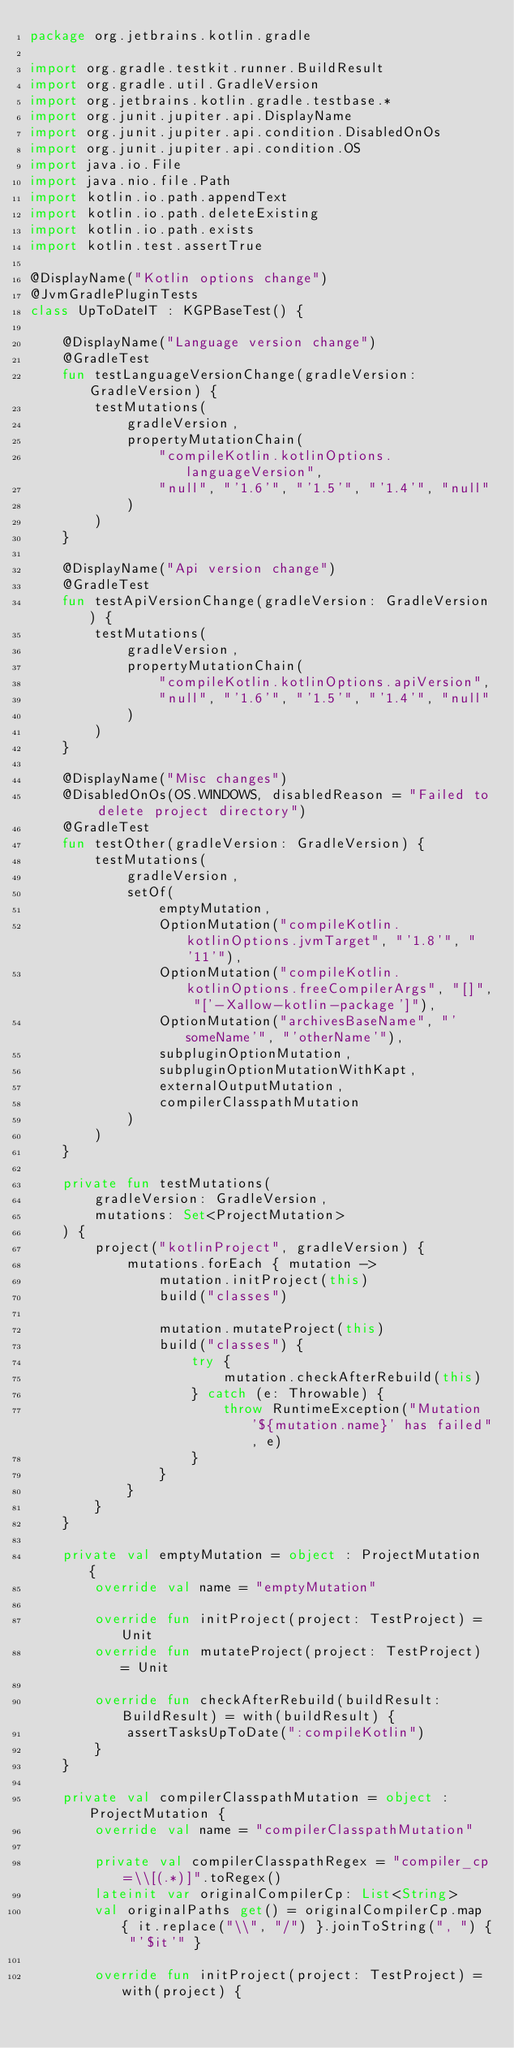<code> <loc_0><loc_0><loc_500><loc_500><_Kotlin_>package org.jetbrains.kotlin.gradle

import org.gradle.testkit.runner.BuildResult
import org.gradle.util.GradleVersion
import org.jetbrains.kotlin.gradle.testbase.*
import org.junit.jupiter.api.DisplayName
import org.junit.jupiter.api.condition.DisabledOnOs
import org.junit.jupiter.api.condition.OS
import java.io.File
import java.nio.file.Path
import kotlin.io.path.appendText
import kotlin.io.path.deleteExisting
import kotlin.io.path.exists
import kotlin.test.assertTrue

@DisplayName("Kotlin options change")
@JvmGradlePluginTests
class UpToDateIT : KGPBaseTest() {

    @DisplayName("Language version change")
    @GradleTest
    fun testLanguageVersionChange(gradleVersion: GradleVersion) {
        testMutations(
            gradleVersion,
            propertyMutationChain(
                "compileKotlin.kotlinOptions.languageVersion",
                "null", "'1.6'", "'1.5'", "'1.4'", "null"
            )
        )
    }

    @DisplayName("Api version change")
    @GradleTest
    fun testApiVersionChange(gradleVersion: GradleVersion) {
        testMutations(
            gradleVersion,
            propertyMutationChain(
                "compileKotlin.kotlinOptions.apiVersion",
                "null", "'1.6'", "'1.5'", "'1.4'", "null"
            )
        )
    }

    @DisplayName("Misc changes")
    @DisabledOnOs(OS.WINDOWS, disabledReason = "Failed to delete project directory")
    @GradleTest
    fun testOther(gradleVersion: GradleVersion) {
        testMutations(
            gradleVersion,
            setOf(
                emptyMutation,
                OptionMutation("compileKotlin.kotlinOptions.jvmTarget", "'1.8'", "'11'"),
                OptionMutation("compileKotlin.kotlinOptions.freeCompilerArgs", "[]", "['-Xallow-kotlin-package']"),
                OptionMutation("archivesBaseName", "'someName'", "'otherName'"),
                subpluginOptionMutation,
                subpluginOptionMutationWithKapt,
                externalOutputMutation,
                compilerClasspathMutation
            )
        )
    }

    private fun testMutations(
        gradleVersion: GradleVersion,
        mutations: Set<ProjectMutation>
    ) {
        project("kotlinProject", gradleVersion) {
            mutations.forEach { mutation ->
                mutation.initProject(this)
                build("classes")

                mutation.mutateProject(this)
                build("classes") {
                    try {
                        mutation.checkAfterRebuild(this)
                    } catch (e: Throwable) {
                        throw RuntimeException("Mutation '${mutation.name}' has failed", e)
                    }
                }
            }
        }
    }

    private val emptyMutation = object : ProjectMutation {
        override val name = "emptyMutation"

        override fun initProject(project: TestProject) = Unit
        override fun mutateProject(project: TestProject) = Unit

        override fun checkAfterRebuild(buildResult: BuildResult) = with(buildResult) {
            assertTasksUpToDate(":compileKotlin")
        }
    }

    private val compilerClasspathMutation = object : ProjectMutation {
        override val name = "compilerClasspathMutation"

        private val compilerClasspathRegex = "compiler_cp=\\[(.*)]".toRegex()
        lateinit var originalCompilerCp: List<String>
        val originalPaths get() = originalCompilerCp.map { it.replace("\\", "/") }.joinToString(", ") { "'$it'" }

        override fun initProject(project: TestProject) = with(project) {</code> 